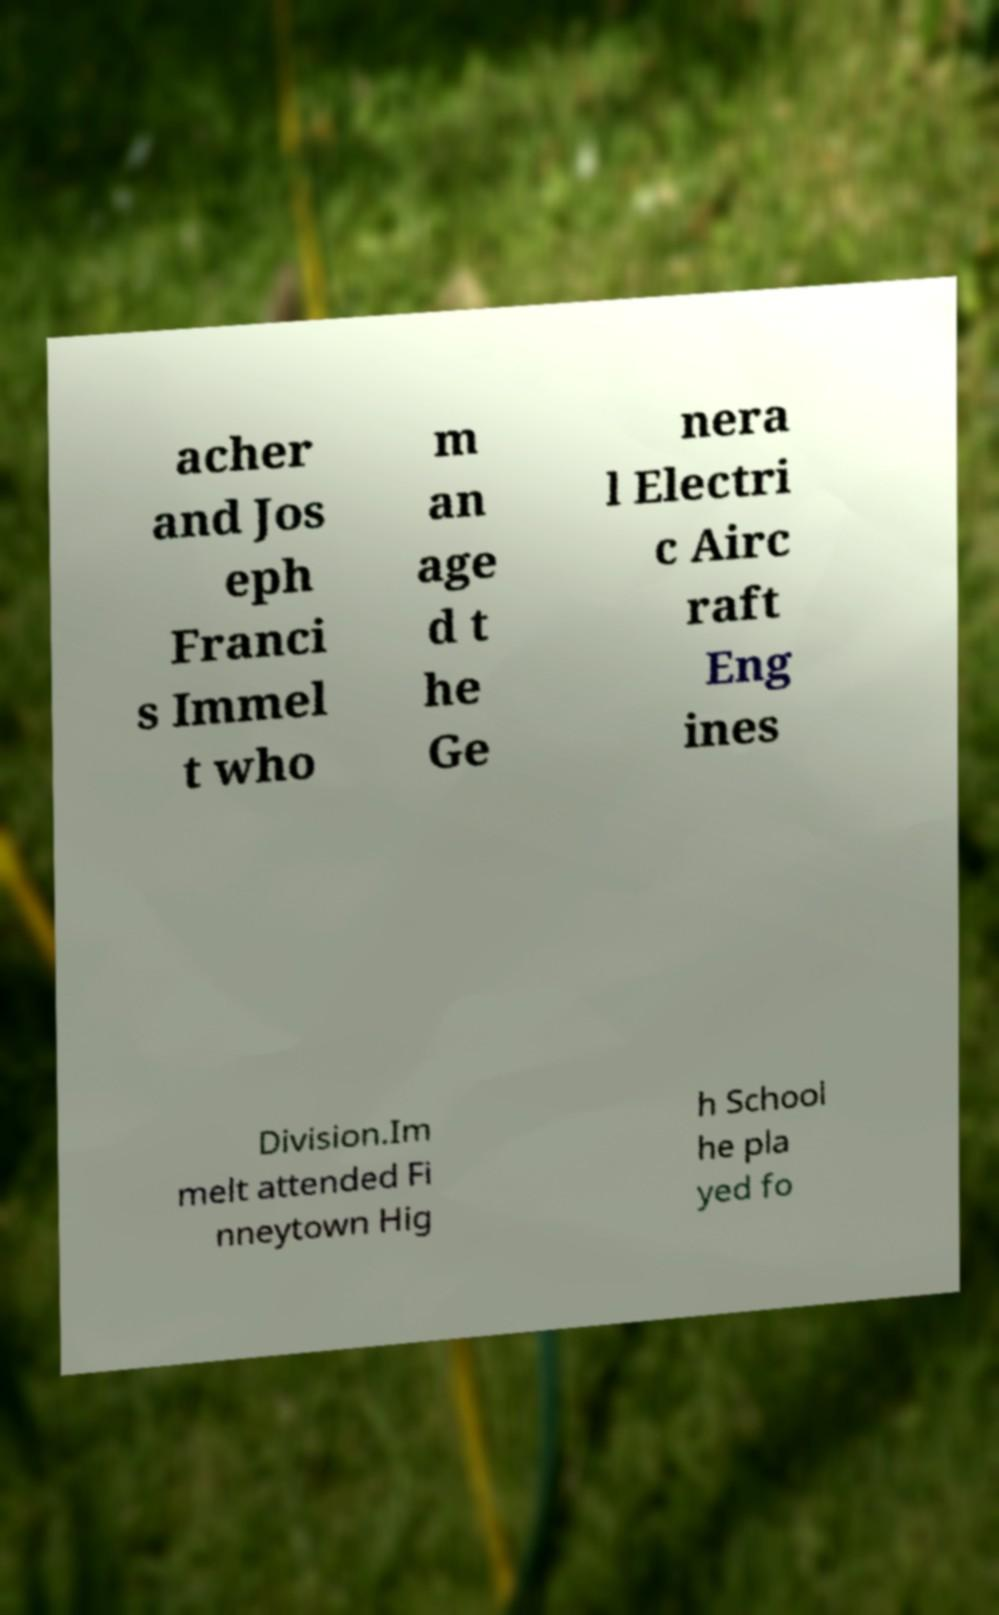I need the written content from this picture converted into text. Can you do that? acher and Jos eph Franci s Immel t who m an age d t he Ge nera l Electri c Airc raft Eng ines Division.Im melt attended Fi nneytown Hig h School he pla yed fo 